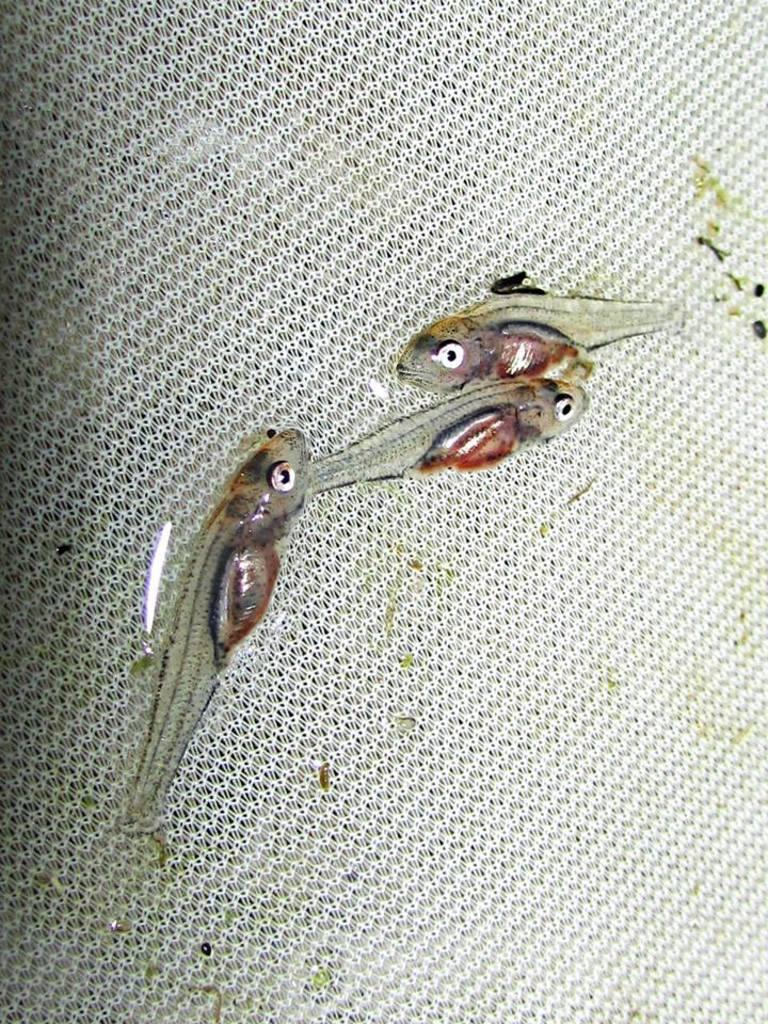How would you summarize this image in a sentence or two? In this picture I can see there are few fishes placed on a white surface. 